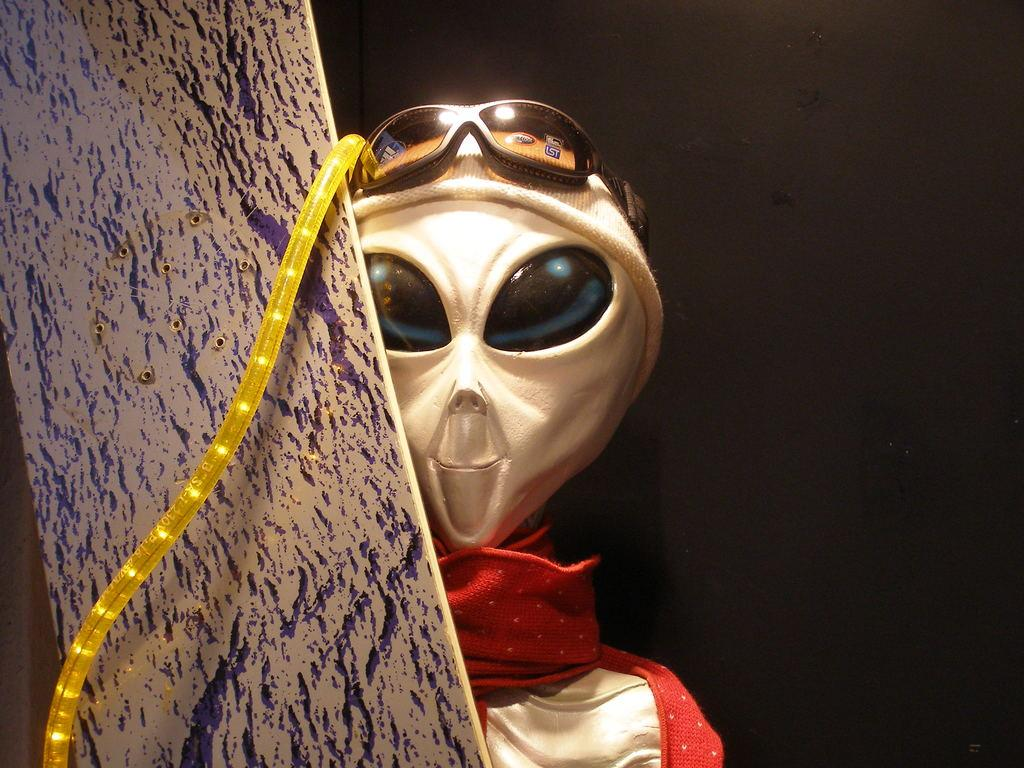What type of toy is in the image? There is an alien toy in the image. What accessories is the alien toy wearing? The alien toy is wearing a red scarf, a white cap, and goggles. What is located on the left side of the image? There is a metal sheet and a light pipe on the left side of the image. How would you describe the overall lighting in the image? The background of the image is dark. Can you see any friends of the alien toy in the image? There are no friends of the alien toy visible in the image. Are there any horses present in the image? There are no horses present in the image. 